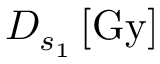<formula> <loc_0><loc_0><loc_500><loc_500>D _ { s _ { 1 } } \, [ G y ]</formula> 